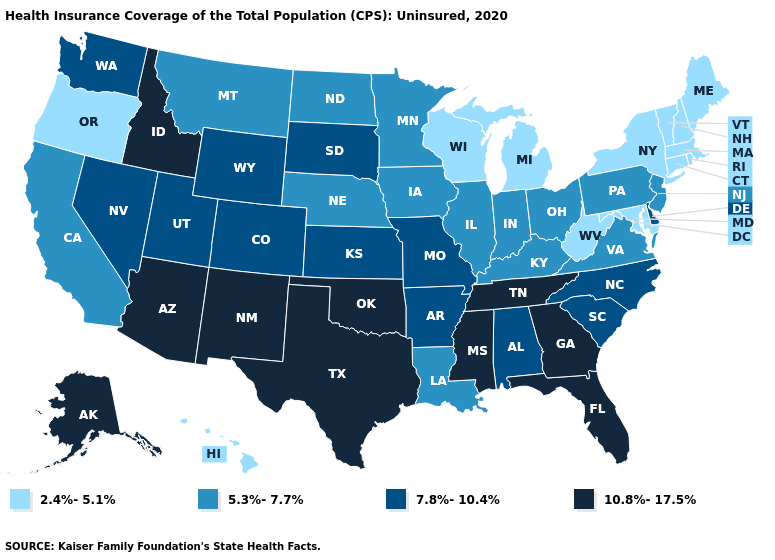Name the states that have a value in the range 10.8%-17.5%?
Keep it brief. Alaska, Arizona, Florida, Georgia, Idaho, Mississippi, New Mexico, Oklahoma, Tennessee, Texas. Does Wyoming have the highest value in the West?
Short answer required. No. Name the states that have a value in the range 7.8%-10.4%?
Write a very short answer. Alabama, Arkansas, Colorado, Delaware, Kansas, Missouri, Nevada, North Carolina, South Carolina, South Dakota, Utah, Washington, Wyoming. Does the first symbol in the legend represent the smallest category?
Quick response, please. Yes. Does the first symbol in the legend represent the smallest category?
Be succinct. Yes. Name the states that have a value in the range 5.3%-7.7%?
Give a very brief answer. California, Illinois, Indiana, Iowa, Kentucky, Louisiana, Minnesota, Montana, Nebraska, New Jersey, North Dakota, Ohio, Pennsylvania, Virginia. Which states have the lowest value in the West?
Give a very brief answer. Hawaii, Oregon. What is the highest value in the USA?
Write a very short answer. 10.8%-17.5%. Does Arkansas have a lower value than Utah?
Write a very short answer. No. Name the states that have a value in the range 7.8%-10.4%?
Keep it brief. Alabama, Arkansas, Colorado, Delaware, Kansas, Missouri, Nevada, North Carolina, South Carolina, South Dakota, Utah, Washington, Wyoming. Name the states that have a value in the range 5.3%-7.7%?
Be succinct. California, Illinois, Indiana, Iowa, Kentucky, Louisiana, Minnesota, Montana, Nebraska, New Jersey, North Dakota, Ohio, Pennsylvania, Virginia. Name the states that have a value in the range 7.8%-10.4%?
Give a very brief answer. Alabama, Arkansas, Colorado, Delaware, Kansas, Missouri, Nevada, North Carolina, South Carolina, South Dakota, Utah, Washington, Wyoming. How many symbols are there in the legend?
Short answer required. 4. Which states have the highest value in the USA?
Give a very brief answer. Alaska, Arizona, Florida, Georgia, Idaho, Mississippi, New Mexico, Oklahoma, Tennessee, Texas. 